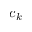Convert formula to latex. <formula><loc_0><loc_0><loc_500><loc_500>c _ { k }</formula> 